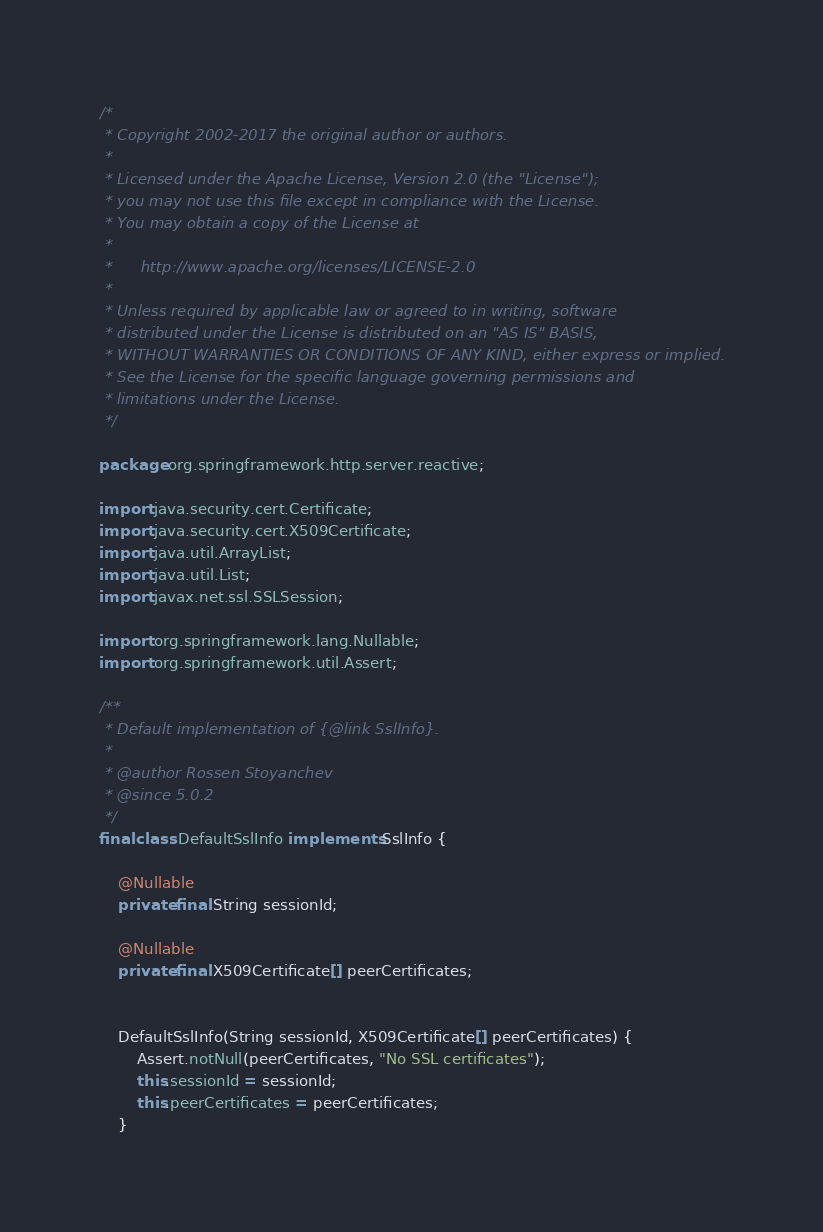<code> <loc_0><loc_0><loc_500><loc_500><_Java_>/*
 * Copyright 2002-2017 the original author or authors.
 *
 * Licensed under the Apache License, Version 2.0 (the "License");
 * you may not use this file except in compliance with the License.
 * You may obtain a copy of the License at
 *
 *      http://www.apache.org/licenses/LICENSE-2.0
 *
 * Unless required by applicable law or agreed to in writing, software
 * distributed under the License is distributed on an "AS IS" BASIS,
 * WITHOUT WARRANTIES OR CONDITIONS OF ANY KIND, either express or implied.
 * See the License for the specific language governing permissions and
 * limitations under the License.
 */

package org.springframework.http.server.reactive;

import java.security.cert.Certificate;
import java.security.cert.X509Certificate;
import java.util.ArrayList;
import java.util.List;
import javax.net.ssl.SSLSession;

import org.springframework.lang.Nullable;
import org.springframework.util.Assert;

/**
 * Default implementation of {@link SslInfo}.
 *
 * @author Rossen Stoyanchev
 * @since 5.0.2
 */
final class DefaultSslInfo implements SslInfo {

	@Nullable
	private final String sessionId;

	@Nullable
	private final X509Certificate[] peerCertificates;


	DefaultSslInfo(String sessionId, X509Certificate[] peerCertificates) {
		Assert.notNull(peerCertificates, "No SSL certificates");
		this.sessionId = sessionId;
		this.peerCertificates = peerCertificates;
	}
</code> 